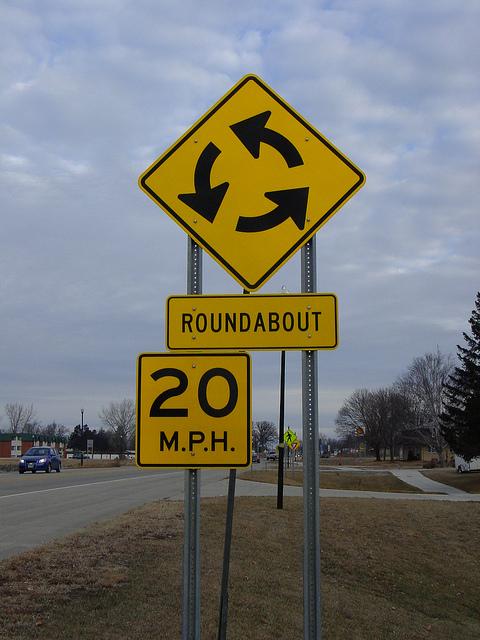What sign is shown?
Answer briefly. Roundabout. Overcast or sunny?
Short answer required. Overcast. What time is it?
Concise answer only. Afternoon. Where is the car?
Concise answer only. Left. What are the color of the sign?
Give a very brief answer. Yellow. What does the bottom sign say?
Keep it brief. 20 mph. How fast is traffic supposed to move down this street?
Quick response, please. 20 mph. What is the number on the sign?
Short answer required. 20. Are the signs rusty?
Be succinct. No. What color is the writing?
Write a very short answer. Black. What language are the signs in?
Concise answer only. English. Is there a stop sign?
Quick response, please. No. How many stripes are on the road?
Keep it brief. 1. What kind of sign is pictured?
Concise answer only. Roundabout. Where is the sign board placed?
Give a very brief answer. By roadside. Are there any clouds in the sky?
Keep it brief. Yes. What is the mph?
Give a very brief answer. 20. What should oncoming traffic do?
Concise answer only. Roundabout. What does the sign say to do?
Keep it brief. Roundabout. Which three directions are allowed at this intersection?
Answer briefly. Circle. What does the sign say?
Quick response, please. Roundabout. What kind of street sign is this?
Quick response, please. Roundabout. What are the words on the sign?
Short answer required. Roundabout. What number is written on the sign?
Give a very brief answer. 20. Is this sign written in English?
Be succinct. Yes. What number is on the sign?
Keep it brief. 20. In which direction is the arrow pointing?
Quick response, please. Round. What letter is in the center of the circle on the sign?
Concise answer only. No letter. What color is the sign?
Write a very short answer. Yellow. What is the sign post made of?
Concise answer only. Metal. Is it cloudy?
Write a very short answer. Yes. What word appears on both signs?
Answer briefly. Roundabout. How many screws are attached to the sign?
Concise answer only. 4. 